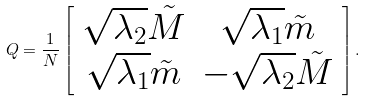<formula> <loc_0><loc_0><loc_500><loc_500>Q = \frac { 1 } { N } \left [ \begin{array} { c c } \sqrt { \lambda _ { 2 } } \tilde { M } & \sqrt { \lambda _ { 1 } } \tilde { m } \\ \sqrt { \lambda _ { 1 } } \tilde { m } & - \sqrt { \lambda _ { 2 } } \tilde { M } \end{array} \right ] .</formula> 